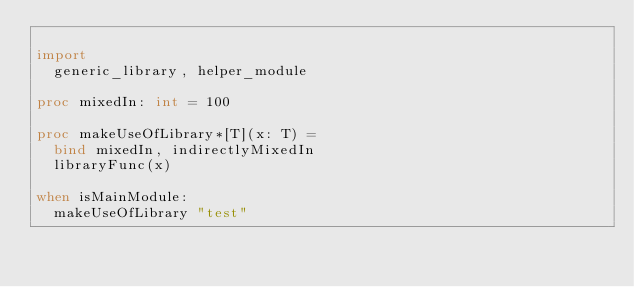<code> <loc_0><loc_0><loc_500><loc_500><_Nim_>
import
  generic_library, helper_module

proc mixedIn: int = 100

proc makeUseOfLibrary*[T](x: T) =
  bind mixedIn, indirectlyMixedIn
  libraryFunc(x)

when isMainModule:
  makeUseOfLibrary "test"
</code> 